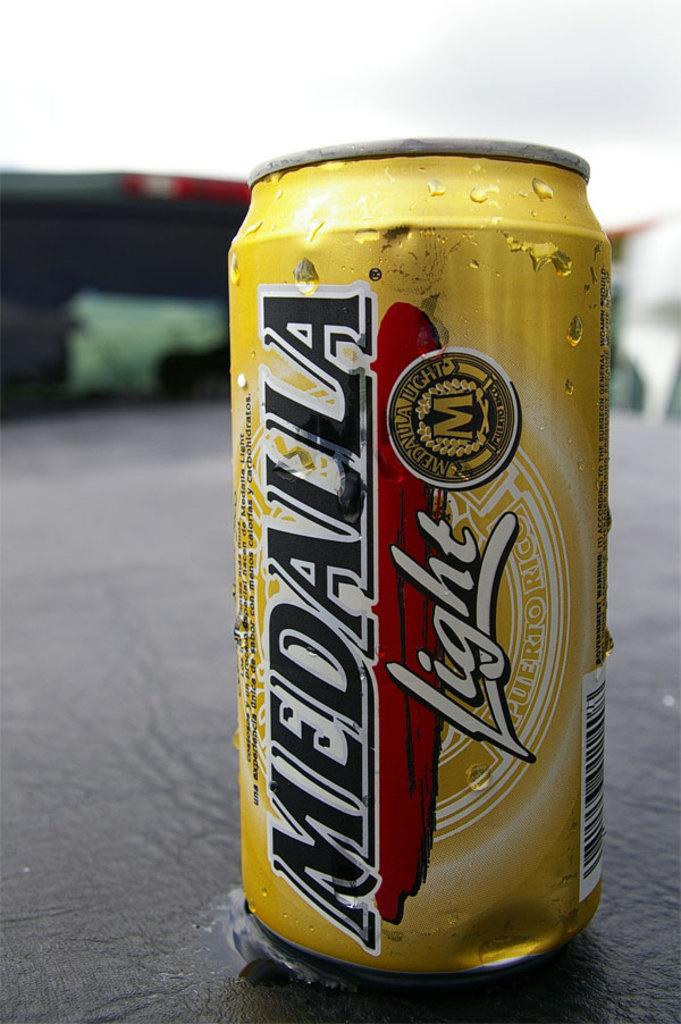What kind of beer is that?
Keep it short and to the point. Medalla. What kind of beer is shown?
Your answer should be compact. Medalla light. 